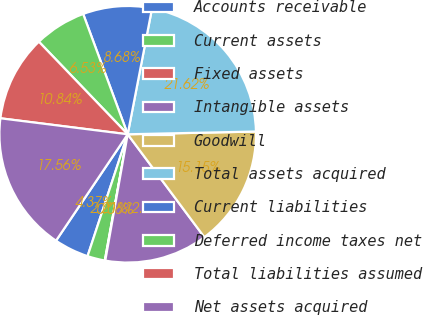Convert chart to OTSL. <chart><loc_0><loc_0><loc_500><loc_500><pie_chart><fcel>Accounts receivable<fcel>Current assets<fcel>Fixed assets<fcel>Intangible assets<fcel>Goodwill<fcel>Total assets acquired<fcel>Current liabilities<fcel>Deferred income taxes net<fcel>Total liabilities assumed<fcel>Net assets acquired<nl><fcel>4.37%<fcel>2.21%<fcel>0.06%<fcel>12.99%<fcel>15.15%<fcel>21.62%<fcel>8.68%<fcel>6.53%<fcel>10.84%<fcel>17.56%<nl></chart> 